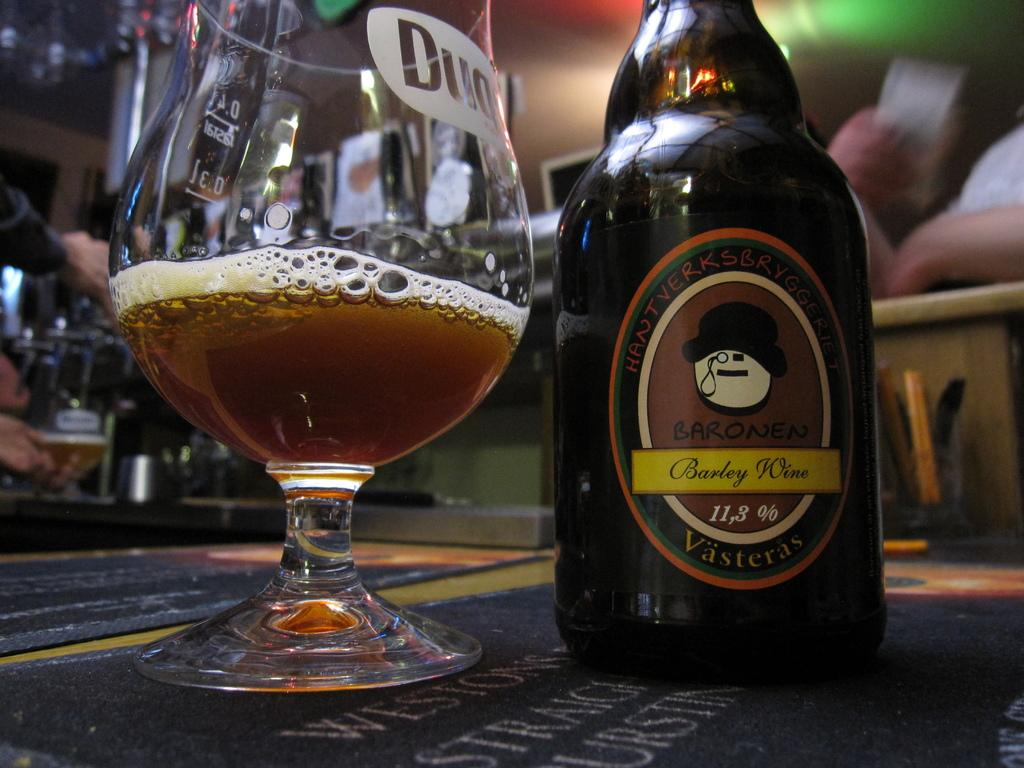<image>
Describe the image concisely. the word Barley is on the beer bottle 